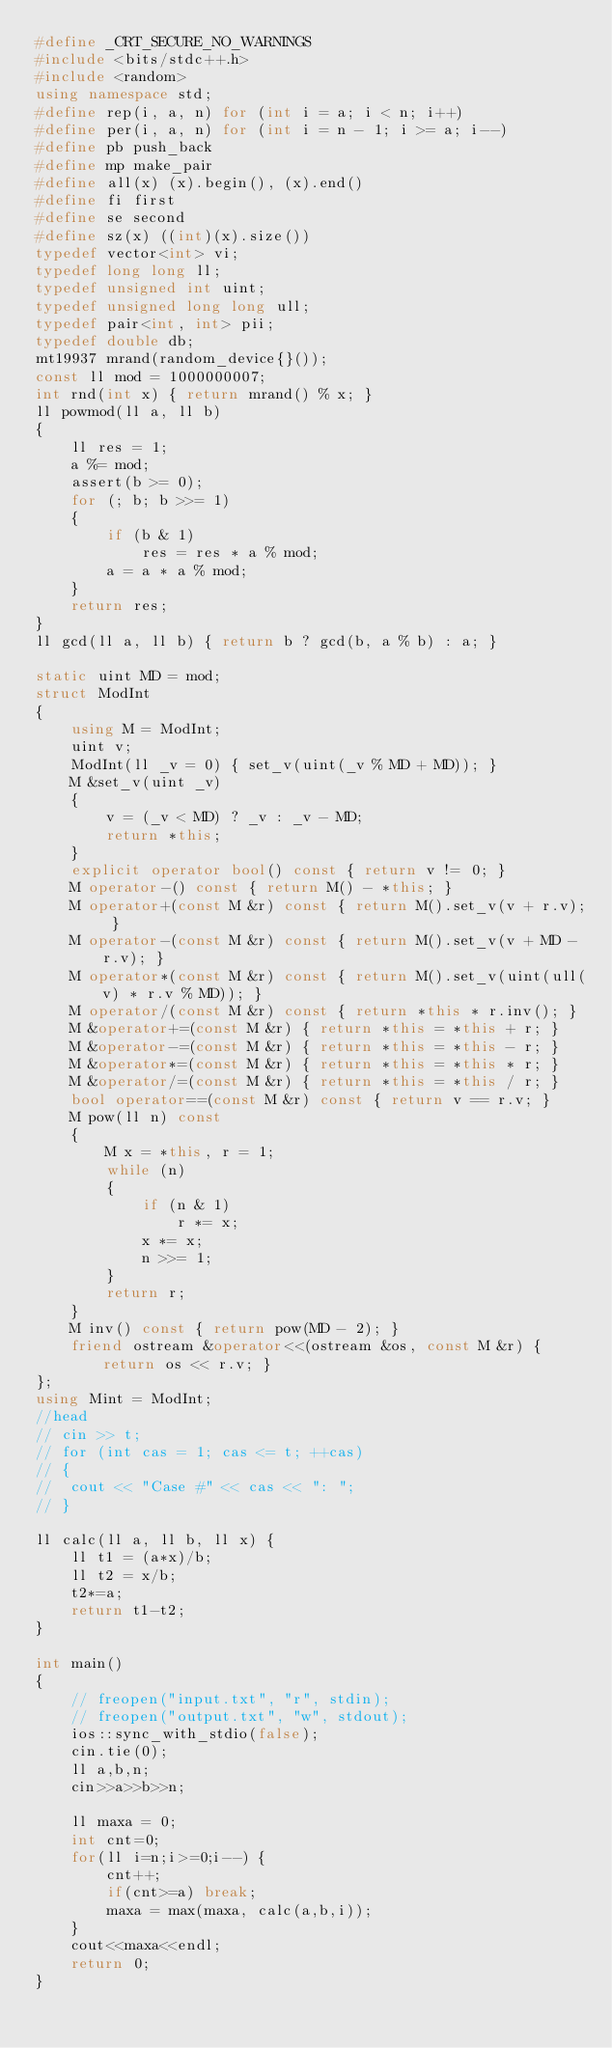Convert code to text. <code><loc_0><loc_0><loc_500><loc_500><_C++_>#define _CRT_SECURE_NO_WARNINGS
#include <bits/stdc++.h>
#include <random>
using namespace std;
#define rep(i, a, n) for (int i = a; i < n; i++)
#define per(i, a, n) for (int i = n - 1; i >= a; i--)
#define pb push_back
#define mp make_pair
#define all(x) (x).begin(), (x).end()
#define fi first
#define se second
#define sz(x) ((int)(x).size())
typedef vector<int> vi;
typedef long long ll;
typedef unsigned int uint;
typedef unsigned long long ull;
typedef pair<int, int> pii;
typedef double db;
mt19937 mrand(random_device{}());
const ll mod = 1000000007;
int rnd(int x) { return mrand() % x; }
ll powmod(ll a, ll b)
{
	ll res = 1;
	a %= mod;
	assert(b >= 0);
	for (; b; b >>= 1)
	{
		if (b & 1)
			res = res * a % mod;
		a = a * a % mod;
	}
	return res;
}
ll gcd(ll a, ll b) { return b ? gcd(b, a % b) : a; }

static uint MD = mod;
struct ModInt
{
	using M = ModInt;
	uint v;
	ModInt(ll _v = 0) { set_v(uint(_v % MD + MD)); }
	M &set_v(uint _v)
	{
		v = (_v < MD) ? _v : _v - MD;
		return *this;
	}
	explicit operator bool() const { return v != 0; }
	M operator-() const { return M() - *this; }
	M operator+(const M &r) const { return M().set_v(v + r.v); }
	M operator-(const M &r) const { return M().set_v(v + MD - r.v); }
	M operator*(const M &r) const { return M().set_v(uint(ull(v) * r.v % MD)); }
	M operator/(const M &r) const { return *this * r.inv(); }
	M &operator+=(const M &r) { return *this = *this + r; }
	M &operator-=(const M &r) { return *this = *this - r; }
	M &operator*=(const M &r) { return *this = *this * r; }
	M &operator/=(const M &r) { return *this = *this / r; }
	bool operator==(const M &r) const { return v == r.v; }
	M pow(ll n) const
	{
		M x = *this, r = 1;
		while (n)
		{
			if (n & 1)
				r *= x;
			x *= x;
			n >>= 1;
		}
		return r;
	}
	M inv() const { return pow(MD - 2); }
	friend ostream &operator<<(ostream &os, const M &r) { return os << r.v; }
};
using Mint = ModInt;
//head
// cin >> t;
// for (int cas = 1; cas <= t; ++cas)
// {
// 	cout << "Case #" << cas << ": ";
// }

ll calc(ll a, ll b, ll x) {
	ll t1 = (a*x)/b;
	ll t2 = x/b;
	t2*=a;
	return t1-t2;
}

int main()
{
	// freopen("input.txt", "r", stdin);
	// freopen("output.txt", "w", stdout);
	ios::sync_with_stdio(false);
	cin.tie(0);
	ll a,b,n;
	cin>>a>>b>>n;
	
	ll maxa = 0;
	int cnt=0;
	for(ll i=n;i>=0;i--) {
		cnt++;
		if(cnt>=a) break;
		maxa = max(maxa, calc(a,b,i));
	}
	cout<<maxa<<endl;
	return 0;
}
</code> 